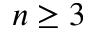<formula> <loc_0><loc_0><loc_500><loc_500>n \geq 3</formula> 